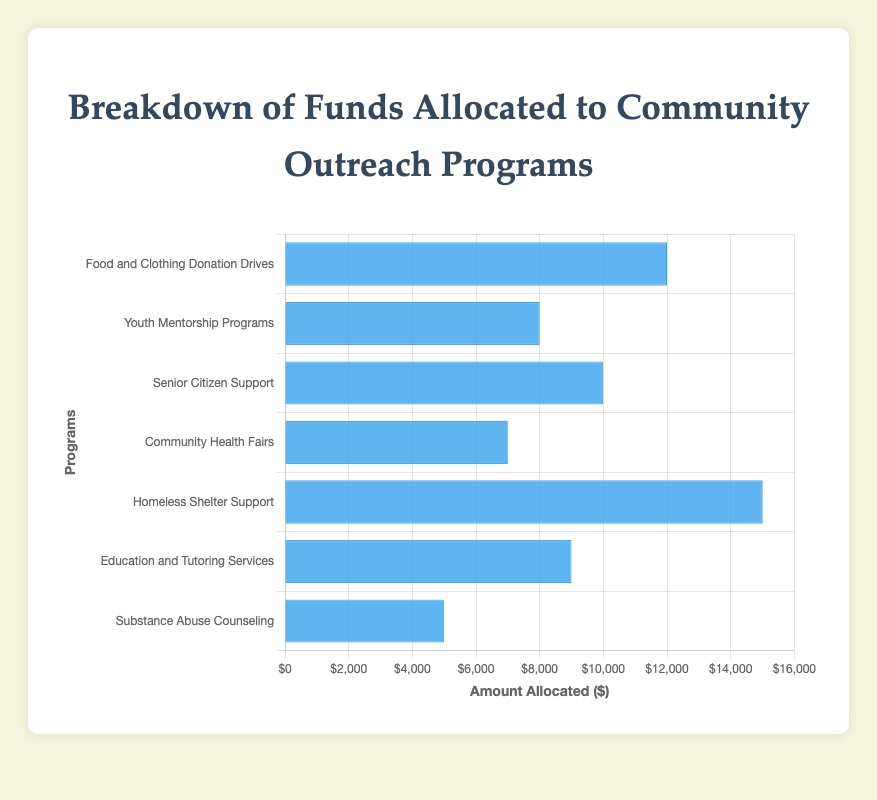Which program receives the most funding? Refer to the height of the blue bars representing each program. The tallest bar indicates the program with the highest funding, which is 'Homeless Shelter Support' at $15,000.
Answer: Homeless Shelter Support What is the total amount allocated to programs that offer support to specific demographics (seniors, youth, substance abuse)? Calculate the sum of amounts allocated to 'Youth Mentorship Programs' ($8,000), 'Senior Citizen Support' ($10,000), and 'Substance Abuse Counseling' ($5,000). Total = $8,000 + $10,000 + $5,000 = $23,000.
Answer: $23,000 Which program has the least amount of funding and how much does it receive? Refer to the shortest blue bar. The shortest bar represents 'Substance Abuse Counseling' which receives $5,000.
Answer: Substance Abuse Counseling, $5,000 Compare the funding differences between 'Food and Clothing Donation Drives' and 'Education and Tutoring Services'. Subtract the amount allocated to 'Education and Tutoring Services' ($9,000) from 'Food and Clothing Donation Drives' ($12,000). Difference = $12,000 - $9,000 = $3,000.
Answer: $3,000 Is the funding for 'Community Health Fairs' greater than 'Senior Citizen Support'? Compare the heights of the bars representing the two programs. 'Community Health Fairs' receives $7,000, and 'Senior Citizen Support' receives $10,000. Therefore, $7,000 is less than $10,000.
Answer: No What is the average amount of funding allocated per program? Sum up all the allocated amounts and divide by the number of programs. ($12,000 + $8,000 + $10,000 + $7,000 + $15,000 + $9,000 + $5,000) / 7 programs = $66,000 / 7 ≈ $9,428.57.
Answer: $9,428.57 How much more funding does 'Homeless Shelter Support' have compared to the average funding per program? Calculate the difference between 'Homeless Shelter Support' ($15,000) and the average funding ($9,428.57). Difference = $15,000 - $9,428.57 ≈ $5,571.43.
Answer: $5,571.43 Which two programs have a combined funding equal to or closest to 'Homeless Shelter Support'? Add combinations of program funds to find the sum equal to or closest to $15,000. 'Senior Citizen Support' ($10,000) + 'Youth Mentorship Programs' ($8,000) = $18,000 or 'Food and Clothing Donation Drives' ($12,000) + 'Substance Abuse Counseling' ($5,000) = $17,000 are closer to $15,000 but exceed it. No exact match.
Answer: None exact What percentage of the total funding is allocated to 'Education and Tutoring Services'? Calculate 'Education and Tutoring Services' funding ($9,000) divided by total funding ($66,000) and multiply by 100. Percentage = ($9,000 / $66,000) * 100 ≈ 13.64%.
Answer: 13.64% Which programs receive more funding than 'Community Health Fairs'? Check bars higher than 'Community Health Fairs' ($7,000). 'Food and Clothing Donation Drives' ($12,000), 'Senior Citizen Support' ($10,000), 'Homeless Shelter Support' ($15,000), and 'Education and Tutoring Services' ($9,000) receive more funding.
Answer: Four programs 